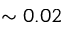Convert formula to latex. <formula><loc_0><loc_0><loc_500><loc_500>\sim 0 . 0 2</formula> 